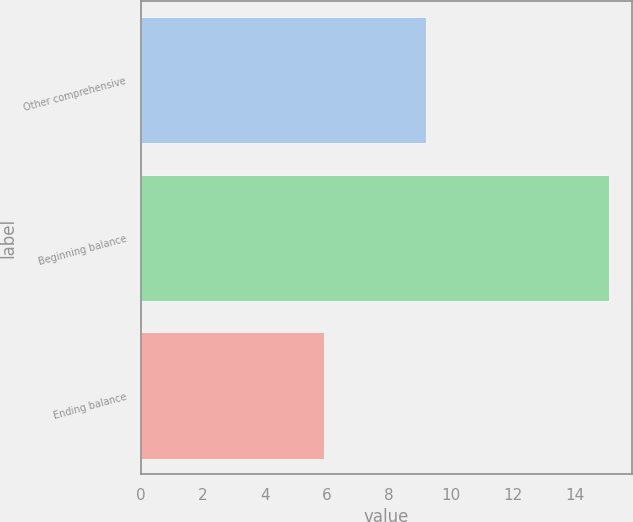<chart> <loc_0><loc_0><loc_500><loc_500><bar_chart><fcel>Other comprehensive<fcel>Beginning balance<fcel>Ending balance<nl><fcel>9.2<fcel>15.1<fcel>5.9<nl></chart> 